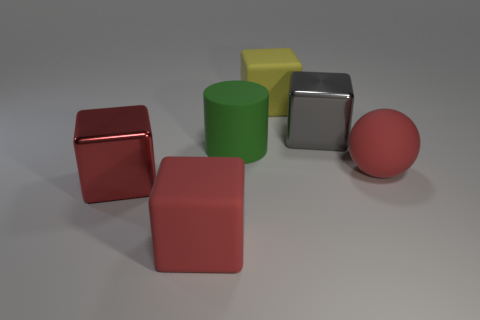Is the number of red balls in front of the red shiny cube less than the number of metallic cubes?
Offer a very short reply. Yes. Are there any other things that have the same shape as the big yellow thing?
Your answer should be compact. Yes. There is another big metal thing that is the same shape as the gray metallic object; what color is it?
Make the answer very short. Red. There is a thing in front of the red metallic thing; does it have the same size as the big yellow rubber thing?
Your answer should be very brief. Yes. How big is the metal cube behind the red rubber thing that is behind the large red metal block?
Provide a short and direct response. Large. Are the yellow cube and the object that is right of the gray metallic thing made of the same material?
Your answer should be compact. Yes. Are there fewer large cubes that are in front of the matte ball than red matte things in front of the rubber cylinder?
Provide a short and direct response. No. What is the color of the cylinder that is the same material as the yellow block?
Your answer should be compact. Green. Is there a big object left of the rubber object that is to the right of the gray metallic block?
Give a very brief answer. Yes. The shiny block that is the same size as the gray metal thing is what color?
Make the answer very short. Red. 